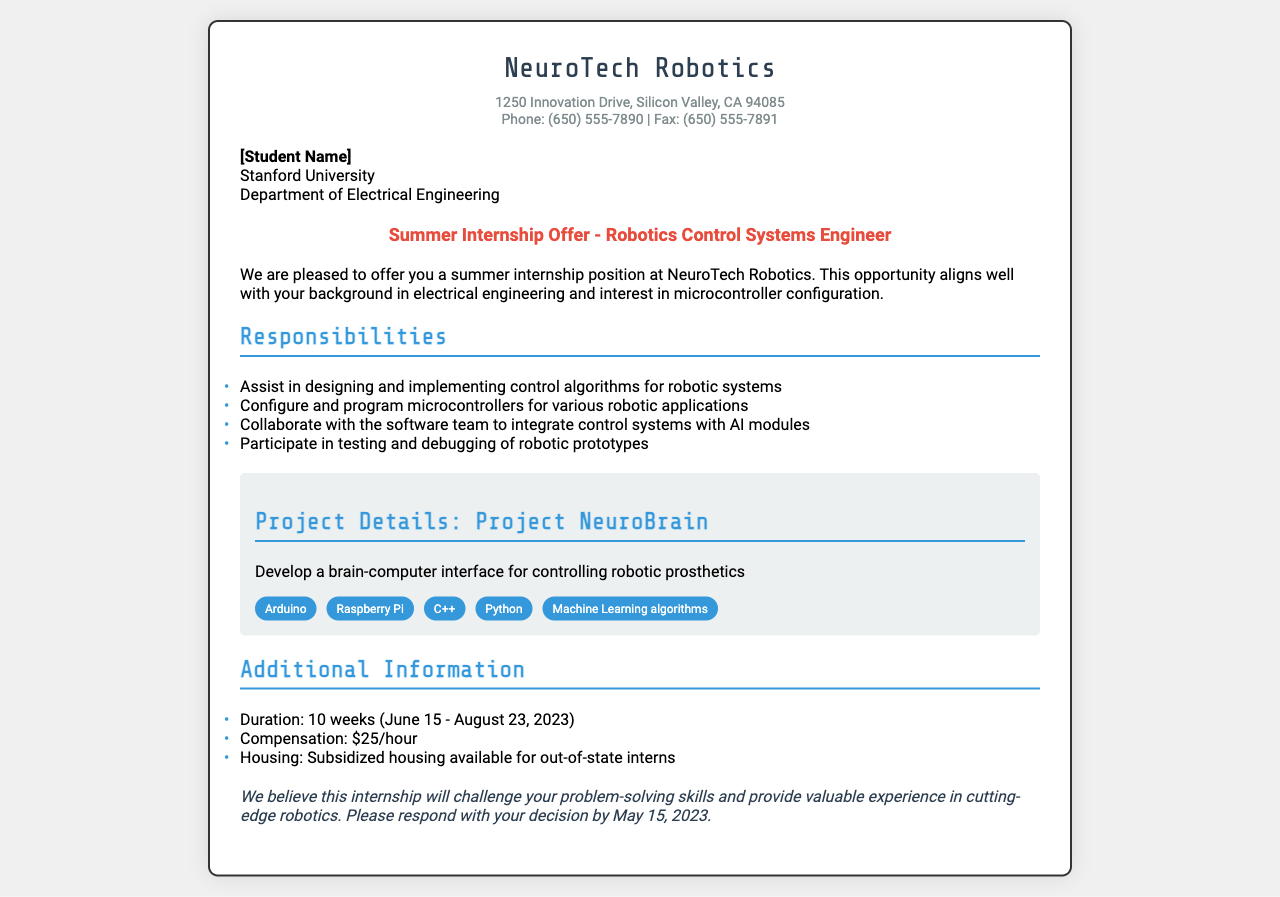What is the name of the company offering the internship? The name of the company is stated in the document's header.
Answer: NeuroTech Robotics What is the position offered in the internship? The document specifies the position in the subject line.
Answer: Robotics Control Systems Engineer What are the dates for the internship? The duration of the internship is explicitly mentioned in the additional information section.
Answer: June 15 - August 23, 2023 What compensation will the intern receive? The compensation is listed in the additional information section of the document.
Answer: $25/hour What is one of the responsibilities of the intern? The responsibilities of the intern are outlined in a list, showing tasks related to robotic systems.
Answer: Assist in designing and implementing control algorithms for robotic systems Which project will the intern work on? The project details section specifies the name of the project.
Answer: Project NeuroBrain What technology is associated with the project? The technologies used in the project are listed within the project details section.
Answer: Arduino What is the main goal of Project NeuroBrain? The document provides a brief description of the project’s goal under its details section.
Answer: Develop a brain-computer interface for controlling robotic prosthetics Is subsidized housing available for interns? The additional information section states whether housing options are provided.
Answer: Yes 